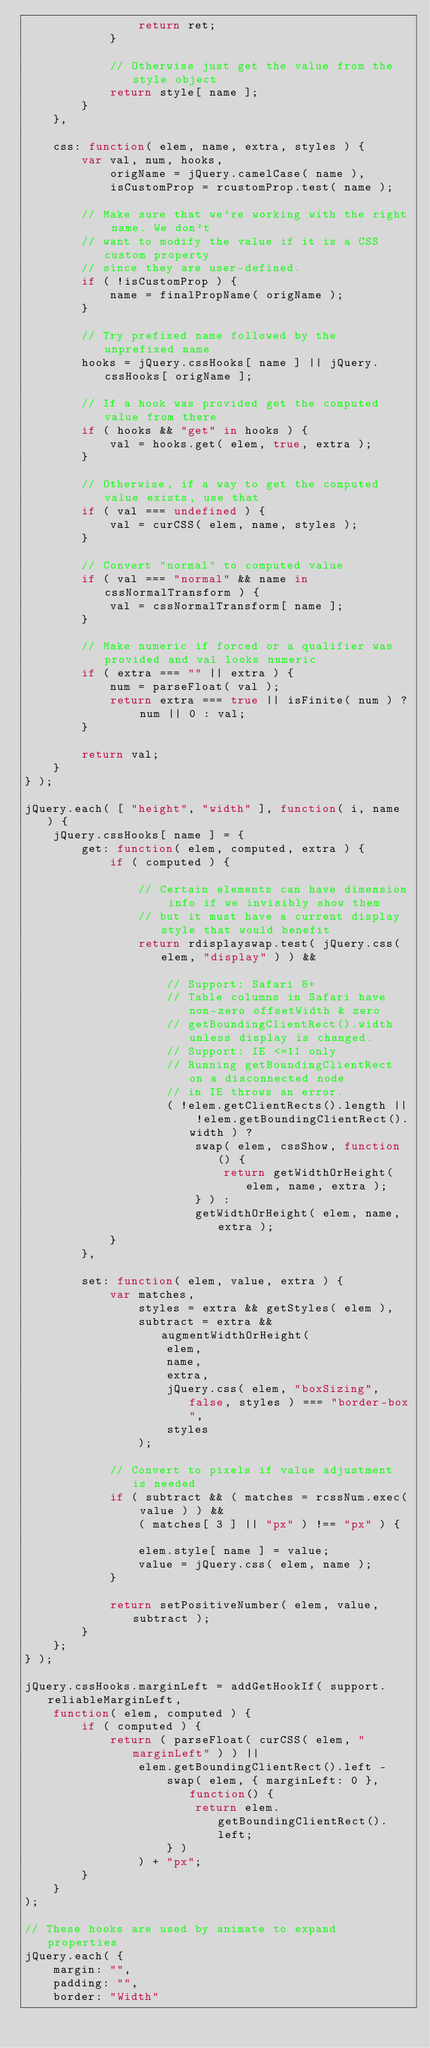Convert code to text. <code><loc_0><loc_0><loc_500><loc_500><_JavaScript_>				return ret;
			}

			// Otherwise just get the value from the style object
			return style[ name ];
		}
	},

	css: function( elem, name, extra, styles ) {
		var val, num, hooks,
			origName = jQuery.camelCase( name ),
			isCustomProp = rcustomProp.test( name );

		// Make sure that we're working with the right name. We don't
		// want to modify the value if it is a CSS custom property
		// since they are user-defined.
		if ( !isCustomProp ) {
			name = finalPropName( origName );
		}

		// Try prefixed name followed by the unprefixed name
		hooks = jQuery.cssHooks[ name ] || jQuery.cssHooks[ origName ];

		// If a hook was provided get the computed value from there
		if ( hooks && "get" in hooks ) {
			val = hooks.get( elem, true, extra );
		}

		// Otherwise, if a way to get the computed value exists, use that
		if ( val === undefined ) {
			val = curCSS( elem, name, styles );
		}

		// Convert "normal" to computed value
		if ( val === "normal" && name in cssNormalTransform ) {
			val = cssNormalTransform[ name ];
		}

		// Make numeric if forced or a qualifier was provided and val looks numeric
		if ( extra === "" || extra ) {
			num = parseFloat( val );
			return extra === true || isFinite( num ) ? num || 0 : val;
		}

		return val;
	}
} );

jQuery.each( [ "height", "width" ], function( i, name ) {
	jQuery.cssHooks[ name ] = {
		get: function( elem, computed, extra ) {
			if ( computed ) {

				// Certain elements can have dimension info if we invisibly show them
				// but it must have a current display style that would benefit
				return rdisplayswap.test( jQuery.css( elem, "display" ) ) &&

					// Support: Safari 8+
					// Table columns in Safari have non-zero offsetWidth & zero
					// getBoundingClientRect().width unless display is changed.
					// Support: IE <=11 only
					// Running getBoundingClientRect on a disconnected node
					// in IE throws an error.
					( !elem.getClientRects().length || !elem.getBoundingClientRect().width ) ?
						swap( elem, cssShow, function() {
							return getWidthOrHeight( elem, name, extra );
						} ) :
						getWidthOrHeight( elem, name, extra );
			}
		},

		set: function( elem, value, extra ) {
			var matches,
				styles = extra && getStyles( elem ),
				subtract = extra && augmentWidthOrHeight(
					elem,
					name,
					extra,
					jQuery.css( elem, "boxSizing", false, styles ) === "border-box",
					styles
				);

			// Convert to pixels if value adjustment is needed
			if ( subtract && ( matches = rcssNum.exec( value ) ) &&
				( matches[ 3 ] || "px" ) !== "px" ) {

				elem.style[ name ] = value;
				value = jQuery.css( elem, name );
			}

			return setPositiveNumber( elem, value, subtract );
		}
	};
} );

jQuery.cssHooks.marginLeft = addGetHookIf( support.reliableMarginLeft,
	function( elem, computed ) {
		if ( computed ) {
			return ( parseFloat( curCSS( elem, "marginLeft" ) ) ||
				elem.getBoundingClientRect().left -
					swap( elem, { marginLeft: 0 }, function() {
						return elem.getBoundingClientRect().left;
					} )
				) + "px";
		}
	}
);

// These hooks are used by animate to expand properties
jQuery.each( {
	margin: "",
	padding: "",
	border: "Width"</code> 